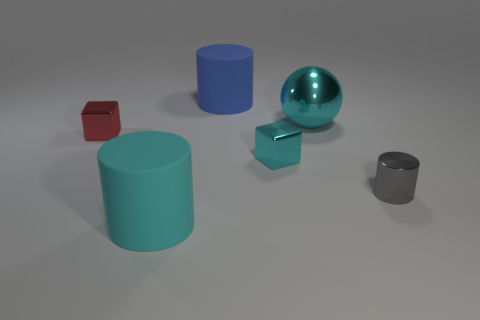There is a metal thing that is in front of the small cyan thing; does it have the same shape as the blue rubber thing?
Give a very brief answer. Yes. There is a matte cylinder behind the cyan shiny block; what color is it?
Offer a very short reply. Blue. What number of other objects are there of the same size as the metal cylinder?
Provide a short and direct response. 2. Are there any other things that are the same shape as the big cyan metal thing?
Your answer should be compact. No. Is the number of small metallic cubes that are on the right side of the gray shiny cylinder the same as the number of large red balls?
Give a very brief answer. Yes. How many small red things are made of the same material as the sphere?
Provide a succinct answer. 1. There is another small cube that is the same material as the tiny cyan cube; what is its color?
Offer a terse response. Red. Is the big blue matte object the same shape as the large cyan rubber object?
Ensure brevity in your answer.  Yes. Is there a large cylinder that is in front of the rubber thing behind the large cyan shiny ball that is behind the tiny gray shiny object?
Your response must be concise. Yes. What number of matte cylinders are the same color as the big sphere?
Give a very brief answer. 1. 